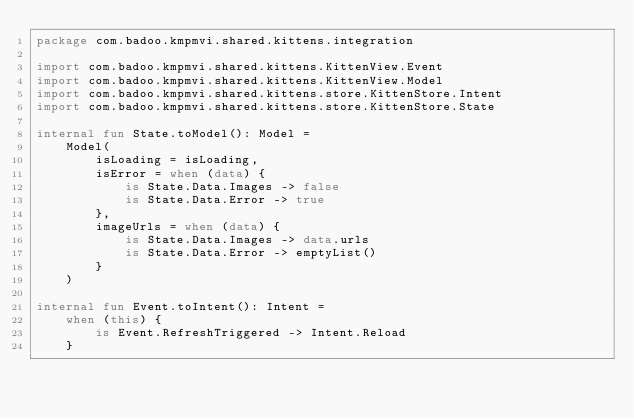<code> <loc_0><loc_0><loc_500><loc_500><_Kotlin_>package com.badoo.kmpmvi.shared.kittens.integration

import com.badoo.kmpmvi.shared.kittens.KittenView.Event
import com.badoo.kmpmvi.shared.kittens.KittenView.Model
import com.badoo.kmpmvi.shared.kittens.store.KittenStore.Intent
import com.badoo.kmpmvi.shared.kittens.store.KittenStore.State

internal fun State.toModel(): Model =
    Model(
        isLoading = isLoading,
        isError = when (data) {
            is State.Data.Images -> false
            is State.Data.Error -> true
        },
        imageUrls = when (data) {
            is State.Data.Images -> data.urls
            is State.Data.Error -> emptyList()
        }
    )

internal fun Event.toIntent(): Intent =
    when (this) {
        is Event.RefreshTriggered -> Intent.Reload
    }
</code> 